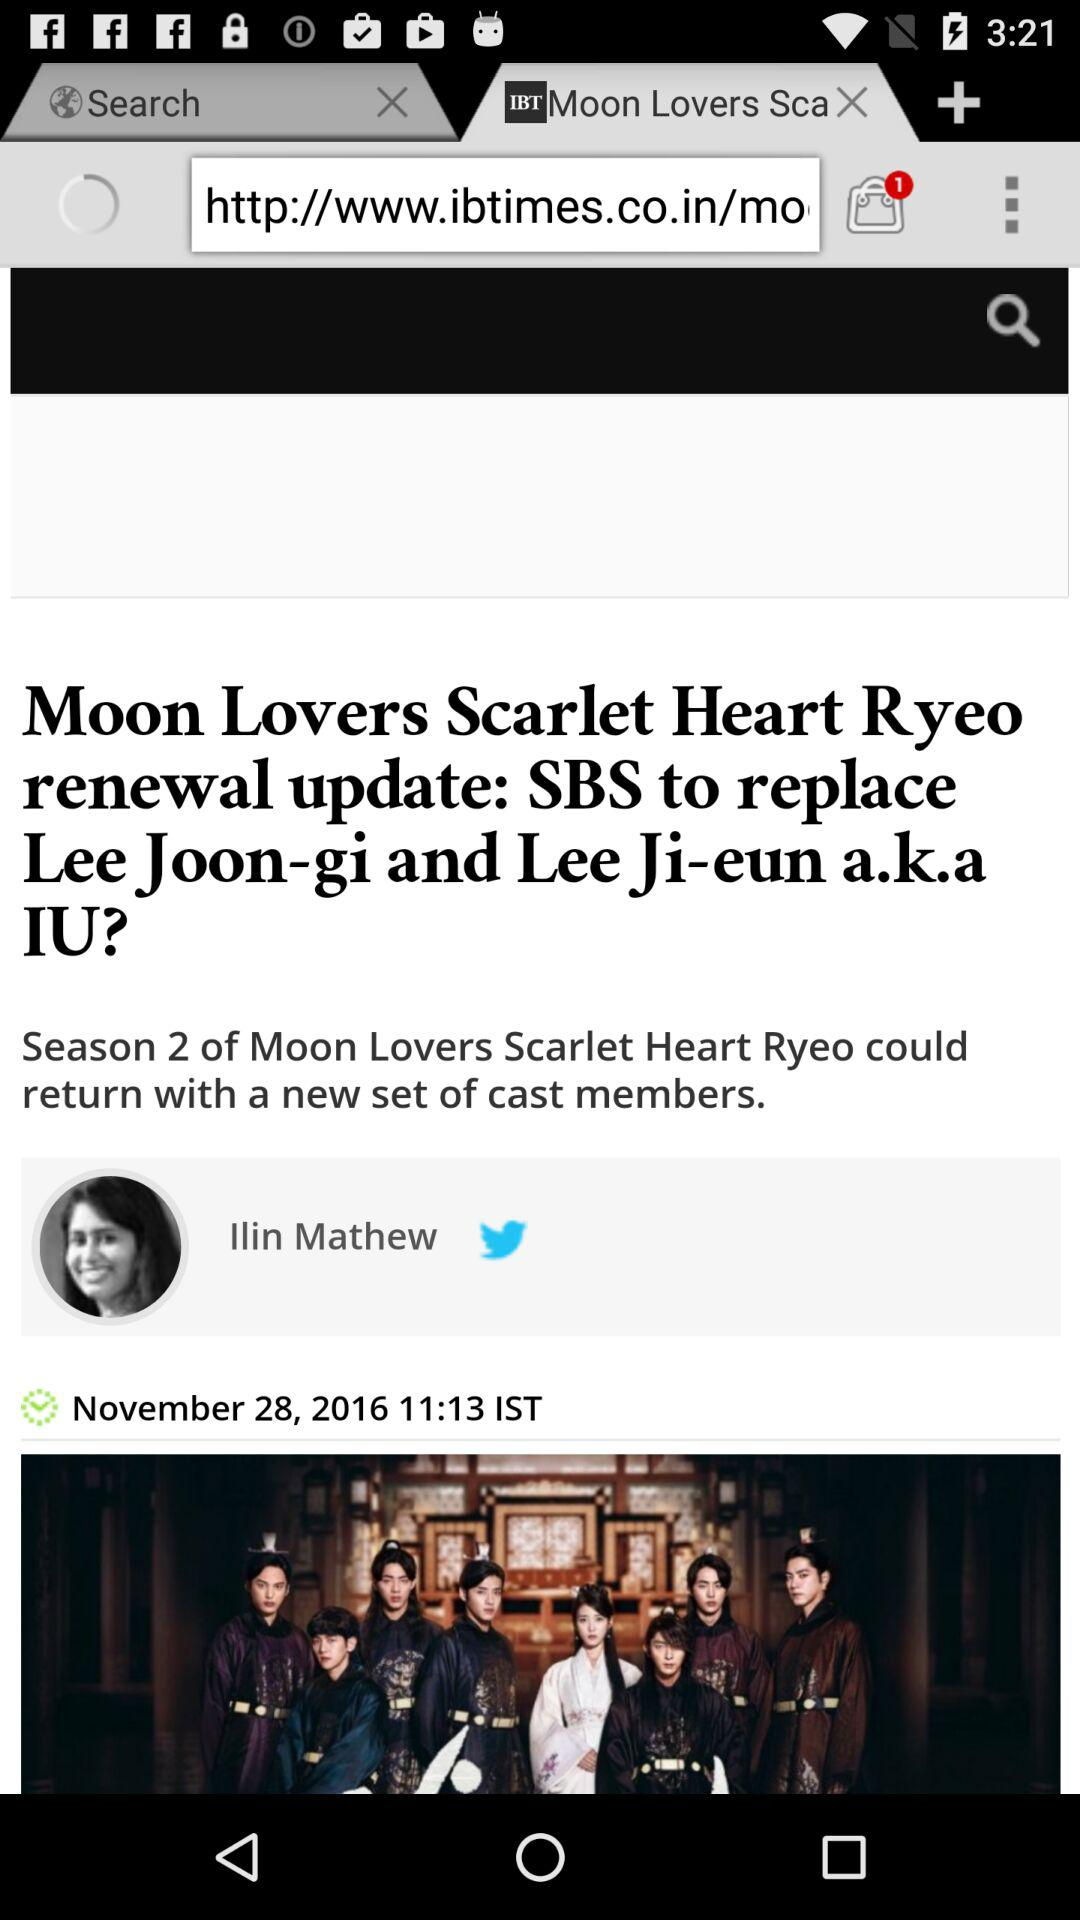What is the author's name? The author's name is Ilin Mathew. 